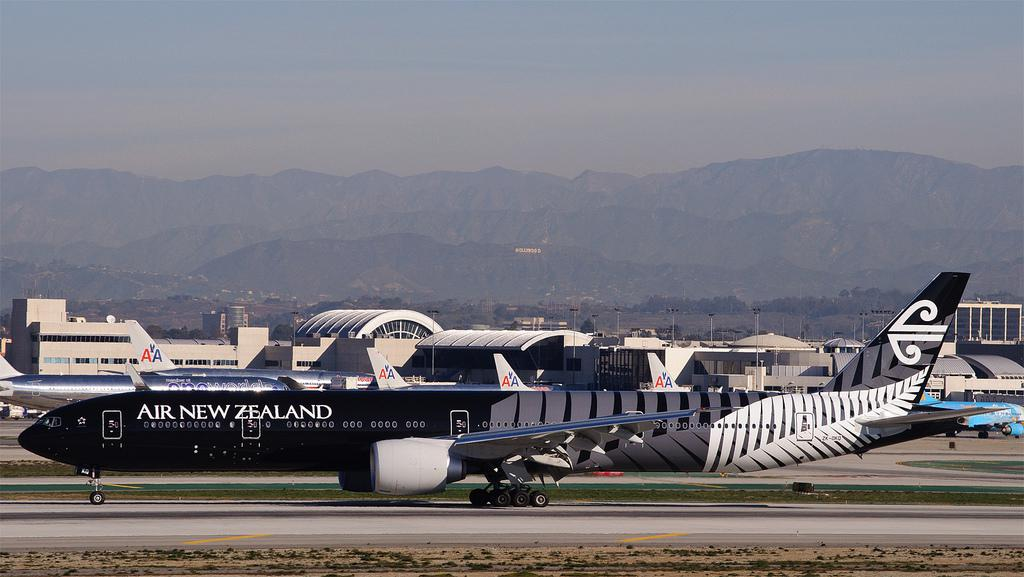Question: what company is the front plane?
Choices:
A. Denmark.
B. Finland.
C. Air new zealand.
D. Air Berlin.
Answer with the letter. Answer: C Question: where is the airplane?
Choices:
A. On the runway.
B. Over the island.
C. In the water.
D. In the air.
Answer with the letter. Answer: A Question: what is in the distance?
Choices:
A. Trees.
B. Shrubs.
C. Lake.
D. Mountains.
Answer with the letter. Answer: D Question: what is in the background, behind the plane?
Choices:
A. An airport terminal.
B. Control tower.
C. A runway.
D. A field.
Answer with the letter. Answer: A Question: who do the planes in the background belong to?
Choices:
A. Jet blue airlines.
B. American airlines.
C. United airlines.
D. Twa airlines.
Answer with the letter. Answer: B Question: how are the airplanes painted?
Choices:
A. With red paint.
B. With green paint.
C. With black,white and grey paint.
D. With blue paint.
Answer with the letter. Answer: C Question: what is the beside the runway?
Choices:
A. A narrow strip of grass.
B. A truck.
C. The airport.
D. Water.
Answer with the letter. Answer: A Question: what is from the maori culture?
Choices:
A. Diamonds.
B. Gems.
C. The airline symbol.
D. Rubies.
Answer with the letter. Answer: C Question: what is in the background?
Choices:
A. A building.
B. A flock of birds.
C. A setting sun.
D. The airplane terminal.
Answer with the letter. Answer: D Question: what shape is the building in the middle?
Choices:
A. It is the Transamerica pyramid.
B. Dome shaped.
C. It is a low flat rectangle.
D. It is square.
Answer with the letter. Answer: B Question: what sits on the tarmac?
Choices:
A. The baggage trailer.
B. Airplanes.
C. The fuel truck.
D. A movable stairway.
Answer with the letter. Answer: B Question: what does the sky look like?
Choices:
A. There is a tall thunderhead.
B. Scattered cirrus clouds.
C. Foggy.
D. Densely covered with cumulus clouds.
Answer with the letter. Answer: C Question: what colors do the planes share?
Choices:
A. White.
B. Blue.
C. Red.
D. Silver.
Answer with the letter. Answer: D Question: what color does the sky appear to be?
Choices:
A. Blue.
B. Black.
C. Green.
D. Gray.
Answer with the letter. Answer: D Question: what color is the plan in the background?
Choices:
A. White.
B. Blue.
C. Light blue.
D. Red.
Answer with the letter. Answer: C Question: what color is the runway?
Choices:
A. Gray.
B. Black.
C. Yellow.
D. Blue.
Answer with the letter. Answer: A 